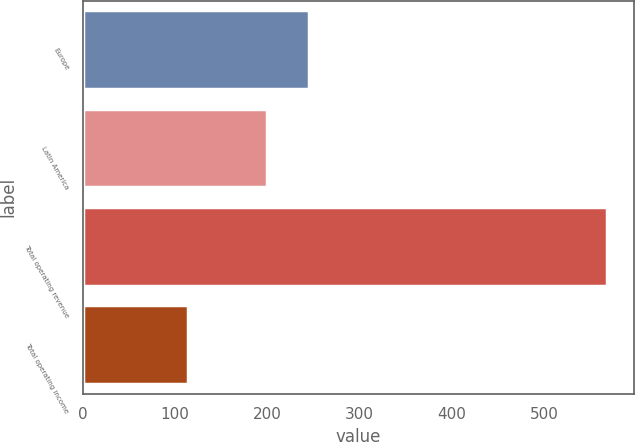Convert chart. <chart><loc_0><loc_0><loc_500><loc_500><bar_chart><fcel>Europe<fcel>Latin America<fcel>Total operating revenue<fcel>Total operating income<nl><fcel>245.1<fcel>199.6<fcel>568.5<fcel>113.5<nl></chart> 